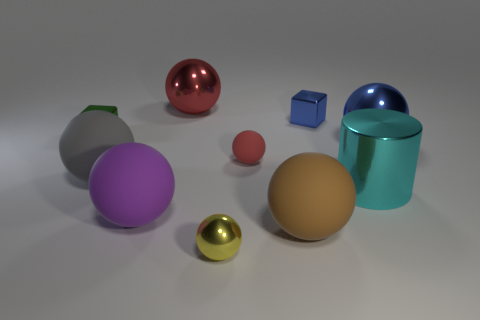Subtract all gray balls. How many balls are left? 6 Subtract all brown cylinders. How many red balls are left? 2 Subtract 1 spheres. How many spheres are left? 6 Subtract all red spheres. How many spheres are left? 5 Subtract all brown spheres. Subtract all yellow blocks. How many spheres are left? 6 Subtract all cylinders. How many objects are left? 9 Subtract all big cyan shiny cylinders. Subtract all large matte things. How many objects are left? 6 Add 8 small rubber things. How many small rubber things are left? 9 Add 3 small red things. How many small red things exist? 4 Subtract 0 red cylinders. How many objects are left? 10 